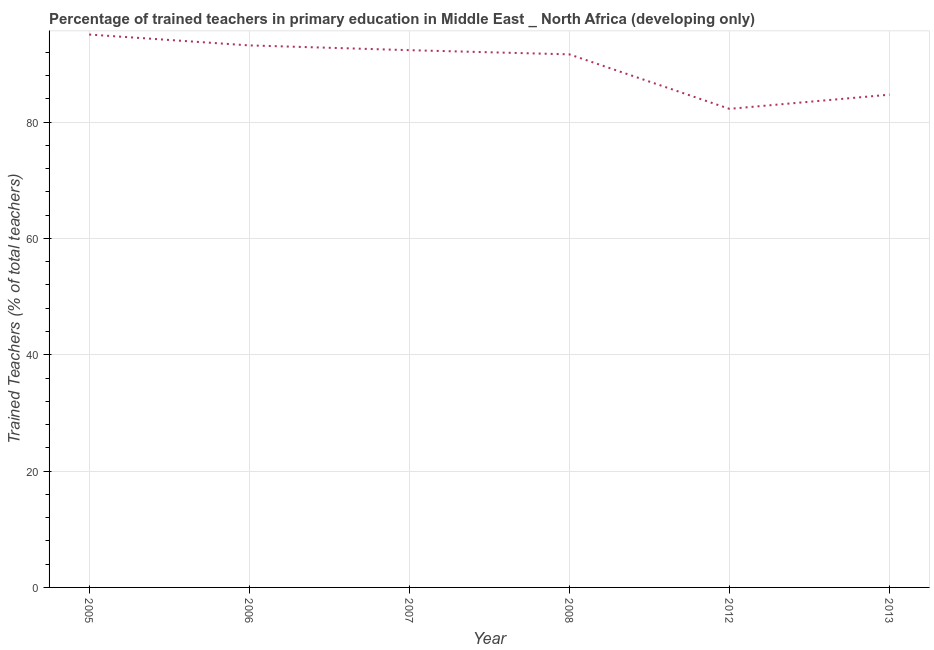What is the percentage of trained teachers in 2005?
Provide a short and direct response. 95.04. Across all years, what is the maximum percentage of trained teachers?
Provide a succinct answer. 95.04. Across all years, what is the minimum percentage of trained teachers?
Keep it short and to the point. 82.27. In which year was the percentage of trained teachers minimum?
Provide a short and direct response. 2012. What is the sum of the percentage of trained teachers?
Offer a terse response. 539.19. What is the difference between the percentage of trained teachers in 2005 and 2012?
Your answer should be very brief. 12.77. What is the average percentage of trained teachers per year?
Ensure brevity in your answer.  89.86. What is the median percentage of trained teachers?
Offer a terse response. 92. Do a majority of the years between 2012 and 2005 (inclusive) have percentage of trained teachers greater than 12 %?
Ensure brevity in your answer.  Yes. What is the ratio of the percentage of trained teachers in 2008 to that in 2013?
Keep it short and to the point. 1.08. What is the difference between the highest and the second highest percentage of trained teachers?
Your response must be concise. 1.86. What is the difference between the highest and the lowest percentage of trained teachers?
Ensure brevity in your answer.  12.77. How many years are there in the graph?
Ensure brevity in your answer.  6. Are the values on the major ticks of Y-axis written in scientific E-notation?
Make the answer very short. No. What is the title of the graph?
Your answer should be compact. Percentage of trained teachers in primary education in Middle East _ North Africa (developing only). What is the label or title of the X-axis?
Your response must be concise. Year. What is the label or title of the Y-axis?
Offer a terse response. Trained Teachers (% of total teachers). What is the Trained Teachers (% of total teachers) of 2005?
Ensure brevity in your answer.  95.04. What is the Trained Teachers (% of total teachers) in 2006?
Offer a terse response. 93.18. What is the Trained Teachers (% of total teachers) of 2007?
Ensure brevity in your answer.  92.36. What is the Trained Teachers (% of total teachers) in 2008?
Keep it short and to the point. 91.64. What is the Trained Teachers (% of total teachers) of 2012?
Provide a short and direct response. 82.27. What is the Trained Teachers (% of total teachers) of 2013?
Make the answer very short. 84.71. What is the difference between the Trained Teachers (% of total teachers) in 2005 and 2006?
Ensure brevity in your answer.  1.86. What is the difference between the Trained Teachers (% of total teachers) in 2005 and 2007?
Your answer should be very brief. 2.69. What is the difference between the Trained Teachers (% of total teachers) in 2005 and 2008?
Your response must be concise. 3.41. What is the difference between the Trained Teachers (% of total teachers) in 2005 and 2012?
Make the answer very short. 12.77. What is the difference between the Trained Teachers (% of total teachers) in 2005 and 2013?
Provide a short and direct response. 10.34. What is the difference between the Trained Teachers (% of total teachers) in 2006 and 2007?
Offer a terse response. 0.82. What is the difference between the Trained Teachers (% of total teachers) in 2006 and 2008?
Offer a terse response. 1.54. What is the difference between the Trained Teachers (% of total teachers) in 2006 and 2012?
Give a very brief answer. 10.91. What is the difference between the Trained Teachers (% of total teachers) in 2006 and 2013?
Provide a short and direct response. 8.47. What is the difference between the Trained Teachers (% of total teachers) in 2007 and 2008?
Provide a succinct answer. 0.72. What is the difference between the Trained Teachers (% of total teachers) in 2007 and 2012?
Provide a short and direct response. 10.09. What is the difference between the Trained Teachers (% of total teachers) in 2007 and 2013?
Provide a short and direct response. 7.65. What is the difference between the Trained Teachers (% of total teachers) in 2008 and 2012?
Offer a terse response. 9.37. What is the difference between the Trained Teachers (% of total teachers) in 2008 and 2013?
Offer a terse response. 6.93. What is the difference between the Trained Teachers (% of total teachers) in 2012 and 2013?
Your response must be concise. -2.44. What is the ratio of the Trained Teachers (% of total teachers) in 2005 to that in 2007?
Provide a short and direct response. 1.03. What is the ratio of the Trained Teachers (% of total teachers) in 2005 to that in 2008?
Make the answer very short. 1.04. What is the ratio of the Trained Teachers (% of total teachers) in 2005 to that in 2012?
Keep it short and to the point. 1.16. What is the ratio of the Trained Teachers (% of total teachers) in 2005 to that in 2013?
Ensure brevity in your answer.  1.12. What is the ratio of the Trained Teachers (% of total teachers) in 2006 to that in 2007?
Make the answer very short. 1.01. What is the ratio of the Trained Teachers (% of total teachers) in 2006 to that in 2012?
Make the answer very short. 1.13. What is the ratio of the Trained Teachers (% of total teachers) in 2006 to that in 2013?
Keep it short and to the point. 1.1. What is the ratio of the Trained Teachers (% of total teachers) in 2007 to that in 2008?
Your response must be concise. 1.01. What is the ratio of the Trained Teachers (% of total teachers) in 2007 to that in 2012?
Provide a short and direct response. 1.12. What is the ratio of the Trained Teachers (% of total teachers) in 2007 to that in 2013?
Provide a short and direct response. 1.09. What is the ratio of the Trained Teachers (% of total teachers) in 2008 to that in 2012?
Your response must be concise. 1.11. What is the ratio of the Trained Teachers (% of total teachers) in 2008 to that in 2013?
Make the answer very short. 1.08. What is the ratio of the Trained Teachers (% of total teachers) in 2012 to that in 2013?
Provide a short and direct response. 0.97. 